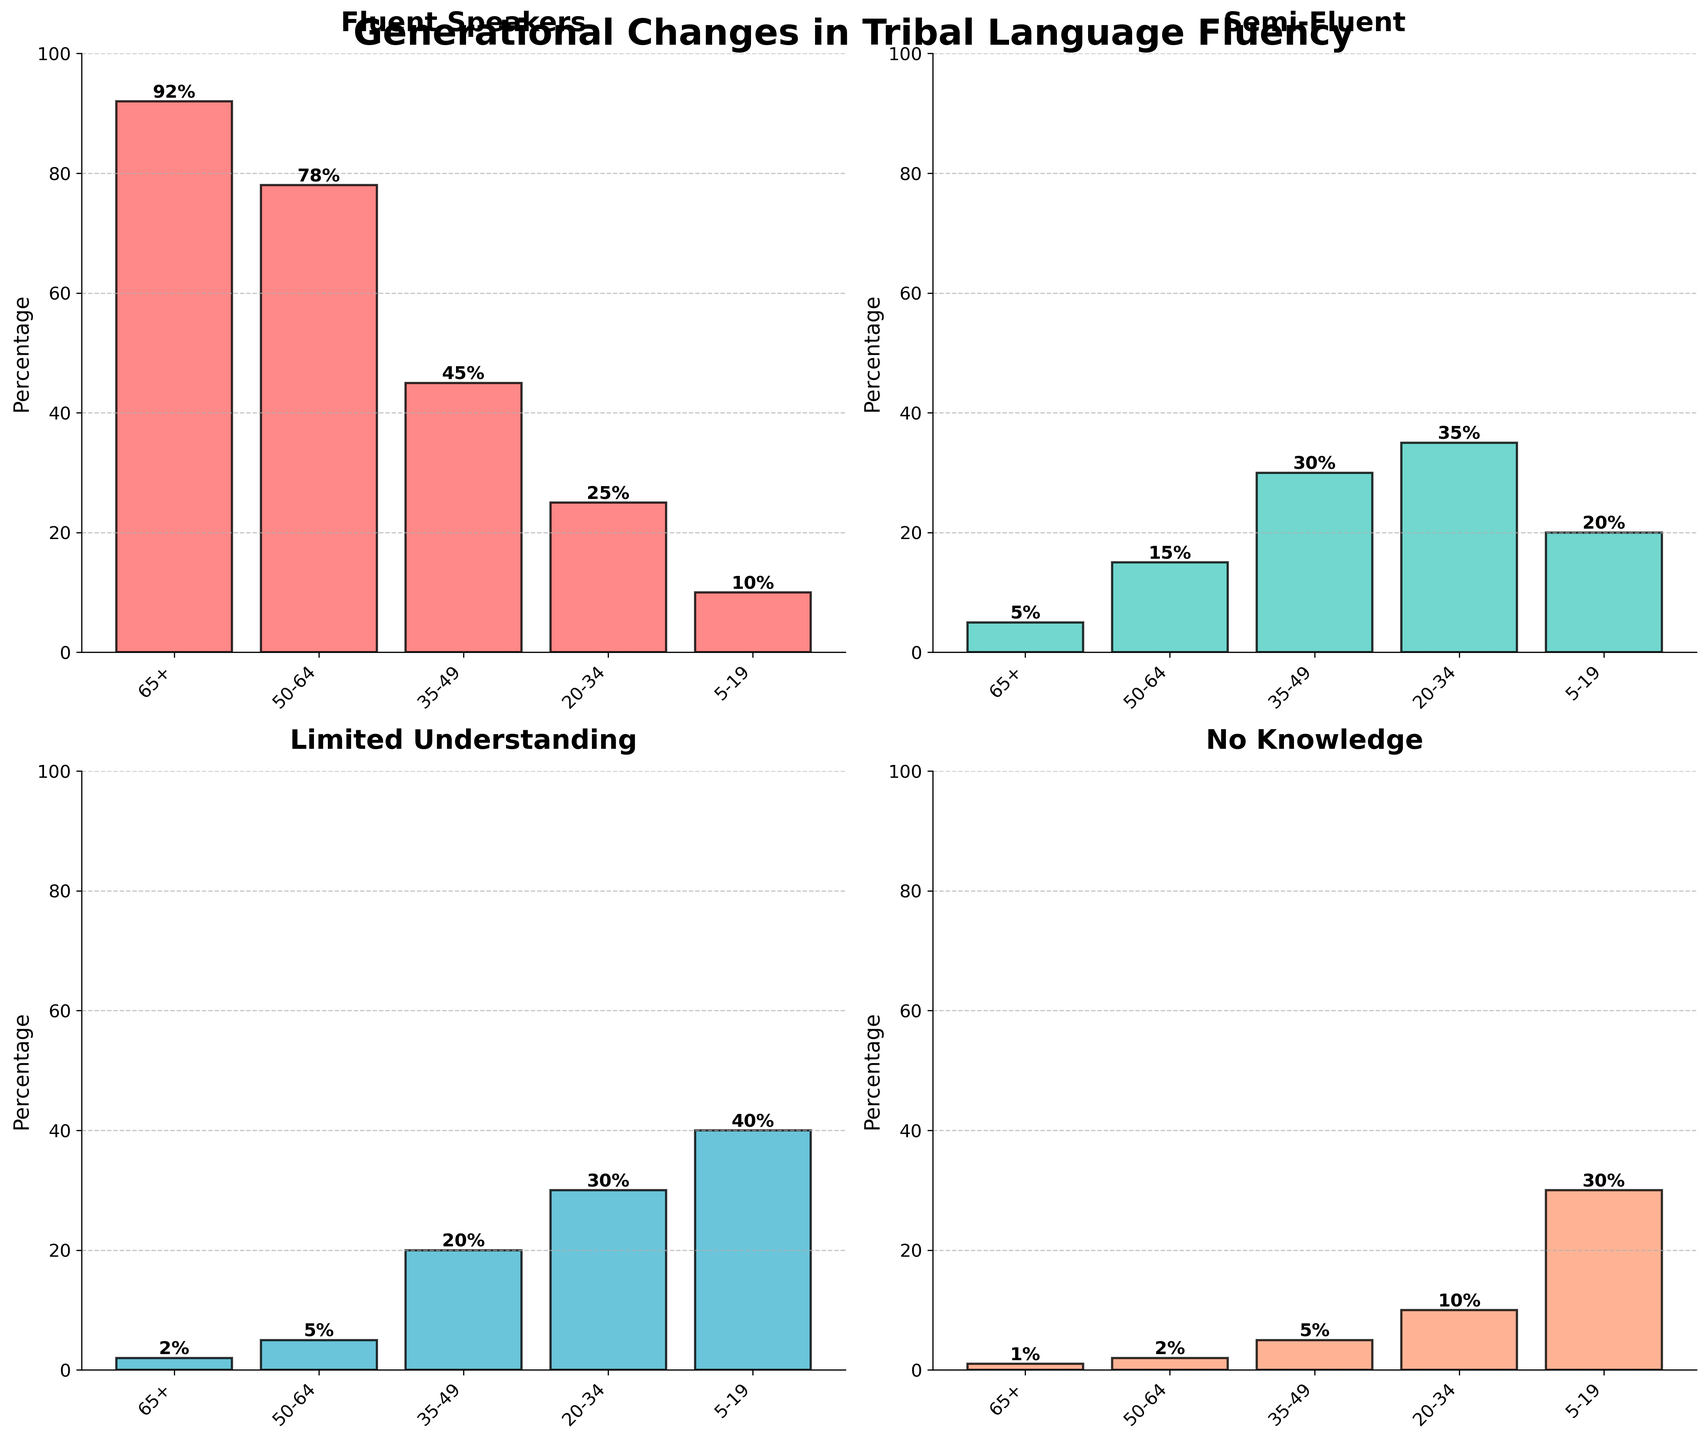Which age group has the highest percentage of fluent speakers? In the subplot titled "Fluent Speakers," the bar representing the "65+" age group is the tallest, showing the highest percentage.
Answer: 65+ What is the total percentage of people aged 5-19 who have limited understanding or no knowledge of the tribal language? The subplot titled "Limited Understanding" shows 40% for ages 5-19, and the subplot titled "No Knowledge" shows 30% for the same age group. Adding these gives 40% + 30% = 70%.
Answer: 70% By how much does the percentage of fluent speakers in the 50-64 age group exceed the percentage in the 35-49 age group? The subplot titled "Fluent Speakers" shows 78% for the 50-64 age group and 45% for the 35-49 age group. The difference is 78% - 45% = 33%.
Answer: 33% What is the trend of language fluency in the younger generations, specifically fluent speakers, across the age groups? Observing the "Fluent Speakers" subplot, the percentage decreases as the age groups go from older to younger: 65+ (92%), 50-64 (78%), 35-49 (45%), 20-34 (25%), and 5-19 (10%).
Answer: Decreasing Which category has the lowest percentage of people aged 50-64? In the subplots, the "No Knowledge" category for the 50-64 age group has the smallest bar, indicating the lowest percentage, comparing it with the rest.
Answer: No Knowledge For the age group 20-34, what is the combined percentage of people who are either semi-fluent or have limited understanding? The subplot titled "Semi-Fluent" shows 35%, and "Limited Understanding" shows 30% for ages 20-34. Adding these gives 35% + 30% = 65%.
Answer: 65% Which age group has the most significant variation in all four categories? By observing all subplots, the 35-49 age group has significant variations across its categories: Fluent Speakers (45%), Semi-Fluent (30%), Limited Understanding (20%), and No Knowledge (5%), indicating diverse language fluency levels.
Answer: 35-49 How does the percentage of no knowledge compare between the oldest and youngest age groups? In the "No Knowledge" subplot, for the 65+ age group the percentage is 1%, and for the 5-19 age group, it is 30%. The comparison shows that the youngest group has a much higher percentage than the oldest.
Answer: The youngest group has a higher percentage What is the average percentage of fluent speakers across all age groups? The percentages of fluent speakers are: 65+ (92%), 50-64 (78%), 35-49 (45%), 20-34 (25%), 5-19 (10%). Summing these gives 250%. The average is calculated as 250% / 5 = 50%.
Answer: 50% 